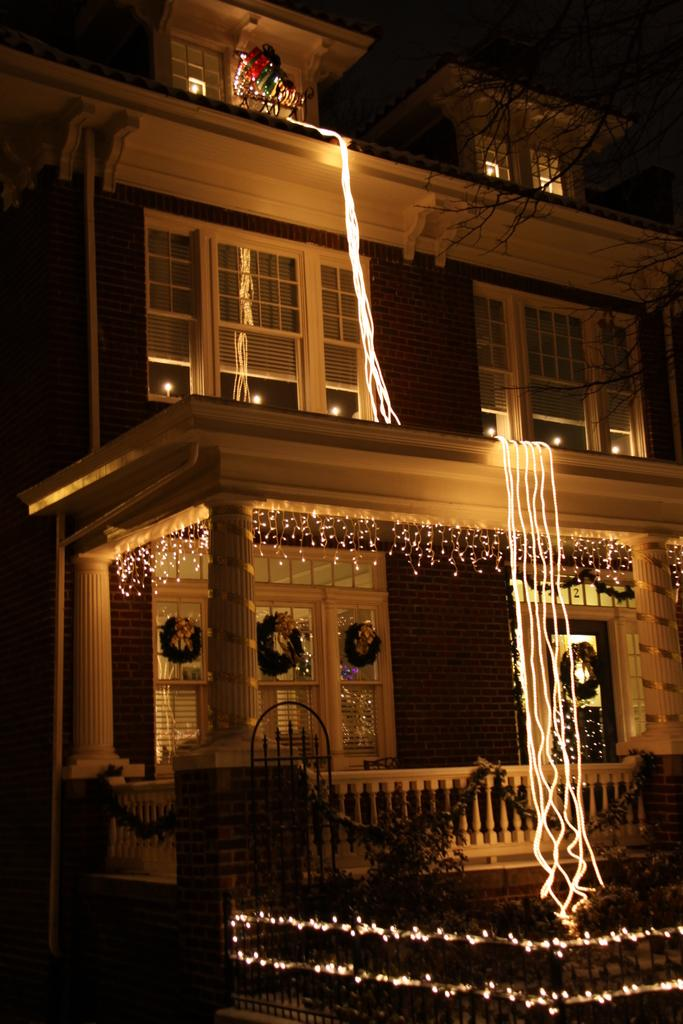What type of structures can be seen in the image? There are buildings in the image. What can be seen illuminating the scene in the image? There are lights in the image. Where is the hydrant located in the image? There is no hydrant present in the image. What type of lamp is visible in the image? There is no lamp present in the image; only lights are visible. 